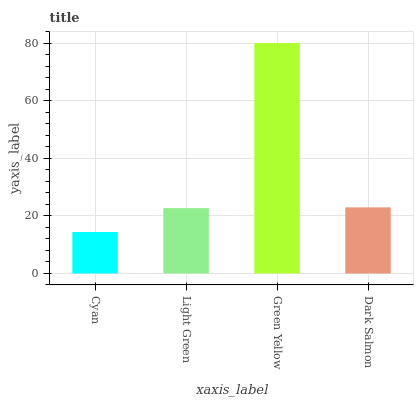Is Cyan the minimum?
Answer yes or no. Yes. Is Green Yellow the maximum?
Answer yes or no. Yes. Is Light Green the minimum?
Answer yes or no. No. Is Light Green the maximum?
Answer yes or no. No. Is Light Green greater than Cyan?
Answer yes or no. Yes. Is Cyan less than Light Green?
Answer yes or no. Yes. Is Cyan greater than Light Green?
Answer yes or no. No. Is Light Green less than Cyan?
Answer yes or no. No. Is Dark Salmon the high median?
Answer yes or no. Yes. Is Light Green the low median?
Answer yes or no. Yes. Is Green Yellow the high median?
Answer yes or no. No. Is Cyan the low median?
Answer yes or no. No. 